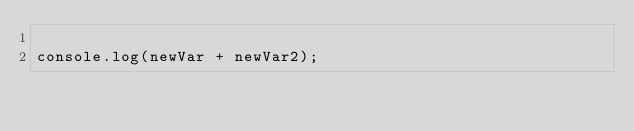<code> <loc_0><loc_0><loc_500><loc_500><_JavaScript_>
console.log(newVar + newVar2);
</code> 